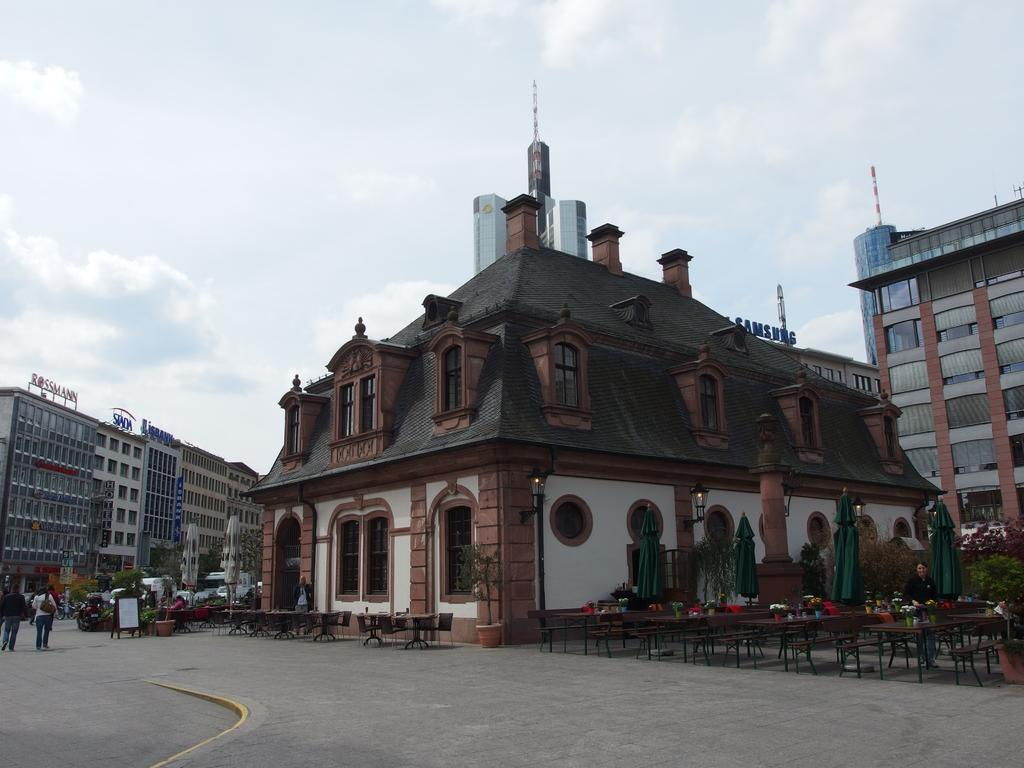What objects are present in the foreground area of the image? In the foreground area, there are chairs, tables, people, plants, vehicles, and umbrellas. What type of structure is visible in the foreground area? There is a building in the foreground area. What can be seen in the background area of the image? In the background area, there are buildings and sky visible. What is the most popular attraction in the image? There is no specific attraction mentioned or visible in the image. What route are the vehicles taking in the image? The image does not provide information about the vehicles' routes. 